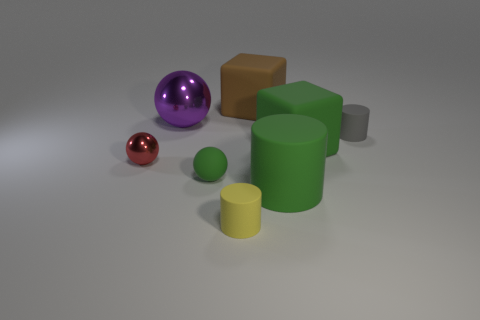Add 2 tiny gray cubes. How many objects exist? 10 Subtract all blocks. How many objects are left? 6 Add 3 small yellow cylinders. How many small yellow cylinders are left? 4 Add 1 small matte things. How many small matte things exist? 4 Subtract 0 cyan blocks. How many objects are left? 8 Subtract all tiny green cylinders. Subtract all green objects. How many objects are left? 5 